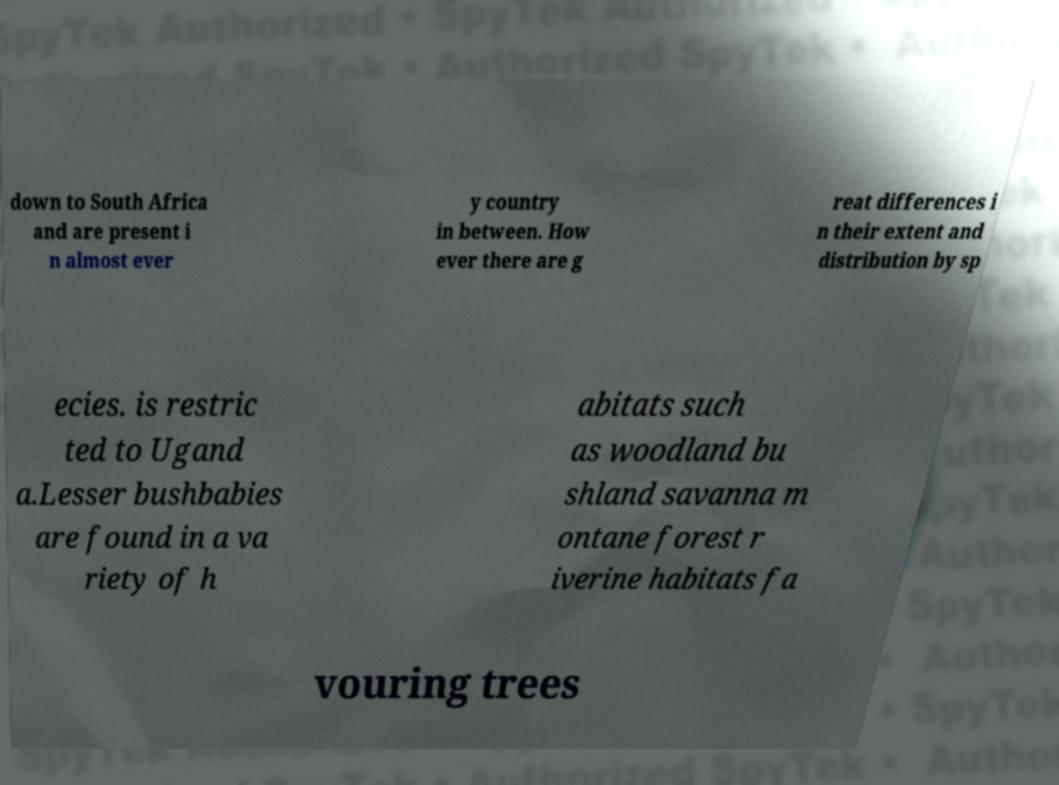Can you read and provide the text displayed in the image?This photo seems to have some interesting text. Can you extract and type it out for me? down to South Africa and are present i n almost ever y country in between. How ever there are g reat differences i n their extent and distribution by sp ecies. is restric ted to Ugand a.Lesser bushbabies are found in a va riety of h abitats such as woodland bu shland savanna m ontane forest r iverine habitats fa vouring trees 